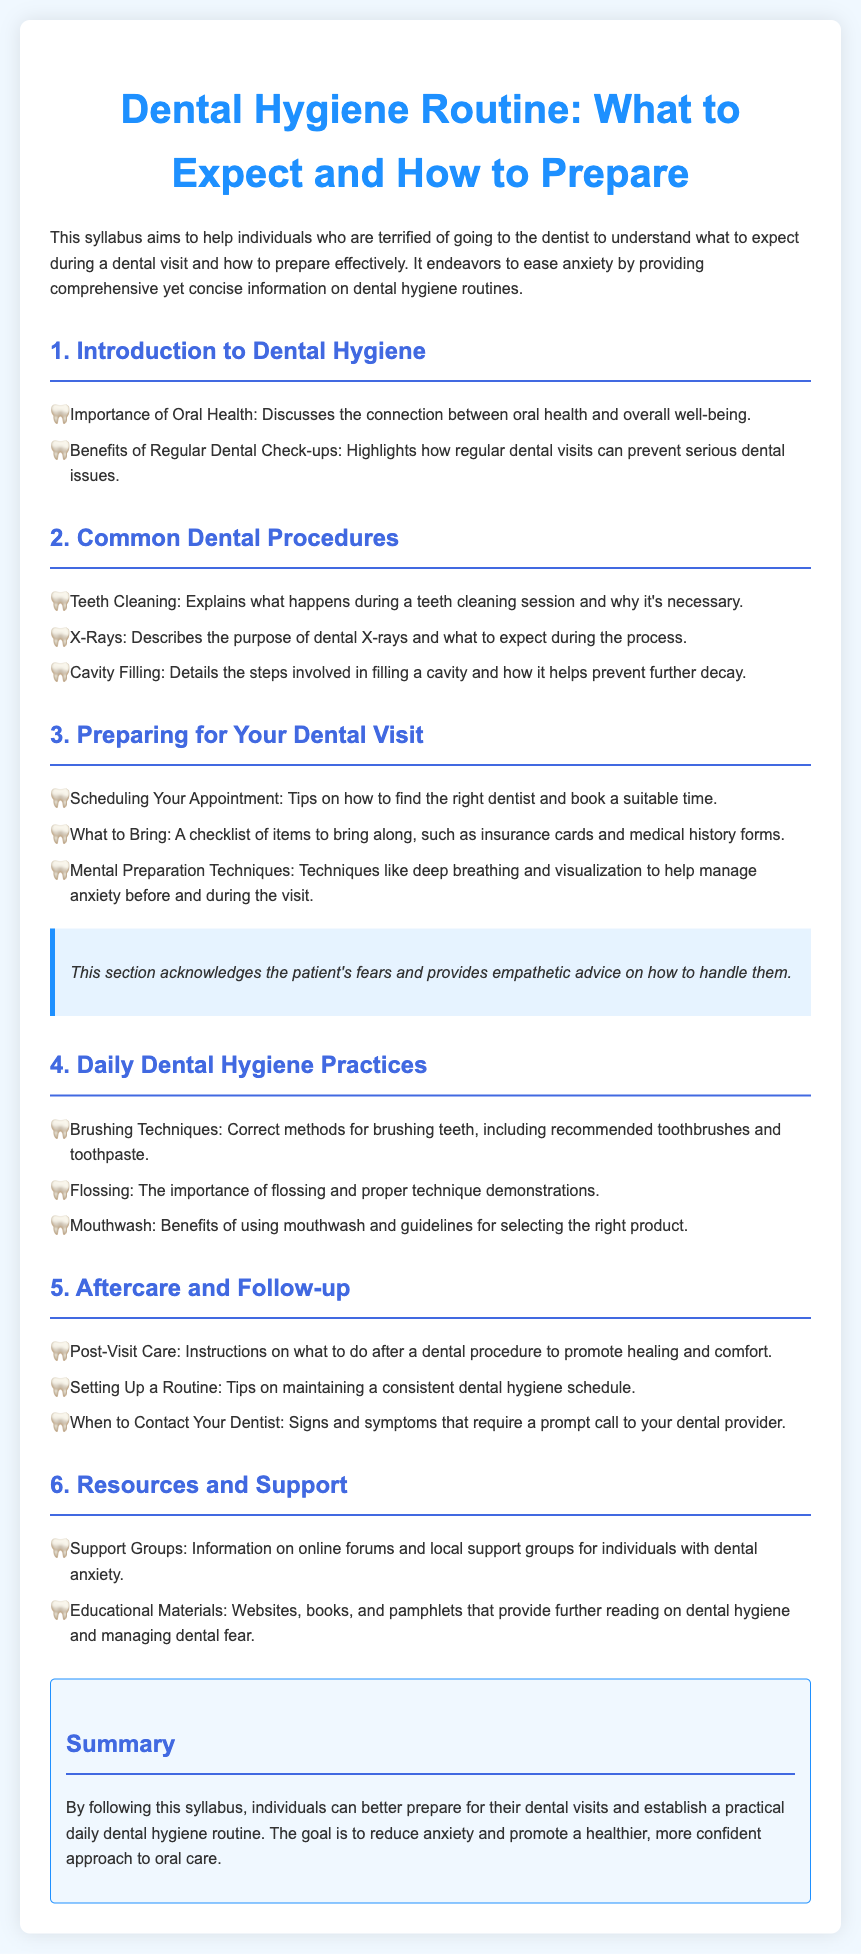What is the title of the syllabus? The title of the syllabus is provided at the top of the document.
Answer: Dental Hygiene Routine: What to Expect and How to Prepare What is one benefit of regular dental check-ups? The document highlights a key benefit of regular visits as part of the dental hygiene routine.
Answer: Prevent serious dental issues What topic is covered under "Common Dental Procedures"? This section explains various standard procedures that patients may encounter during dental visits.
Answer: Teeth Cleaning What should you bring to your dental appointment? The syllabus includes a checklist of items needed for a dental visit.
Answer: Insurance cards What technique is recommended for managing anxiety before a visit? The document suggests mental preparation techniques to alleviate fear prior to dental appointments.
Answer: Deep breathing How many sections are in the syllabus? The number of distinct sections can be counted from the document headings.
Answer: Six What is emphasized in the "Aftercare and Follow-up" section? This section offers guidance on the necessary steps after a dental procedure.
Answer: Post-Visit Care What type of resources are suggested for dental anxiety? The syllabus provides suggestions for additional support and educational materials related to dental anxiety.
Answer: Support Groups What is the purpose of the syllabus? The introduction describes the overarching goal that the syllabus aims to achieve.
Answer: Reduce anxiety and promote a healthier approach to oral care 